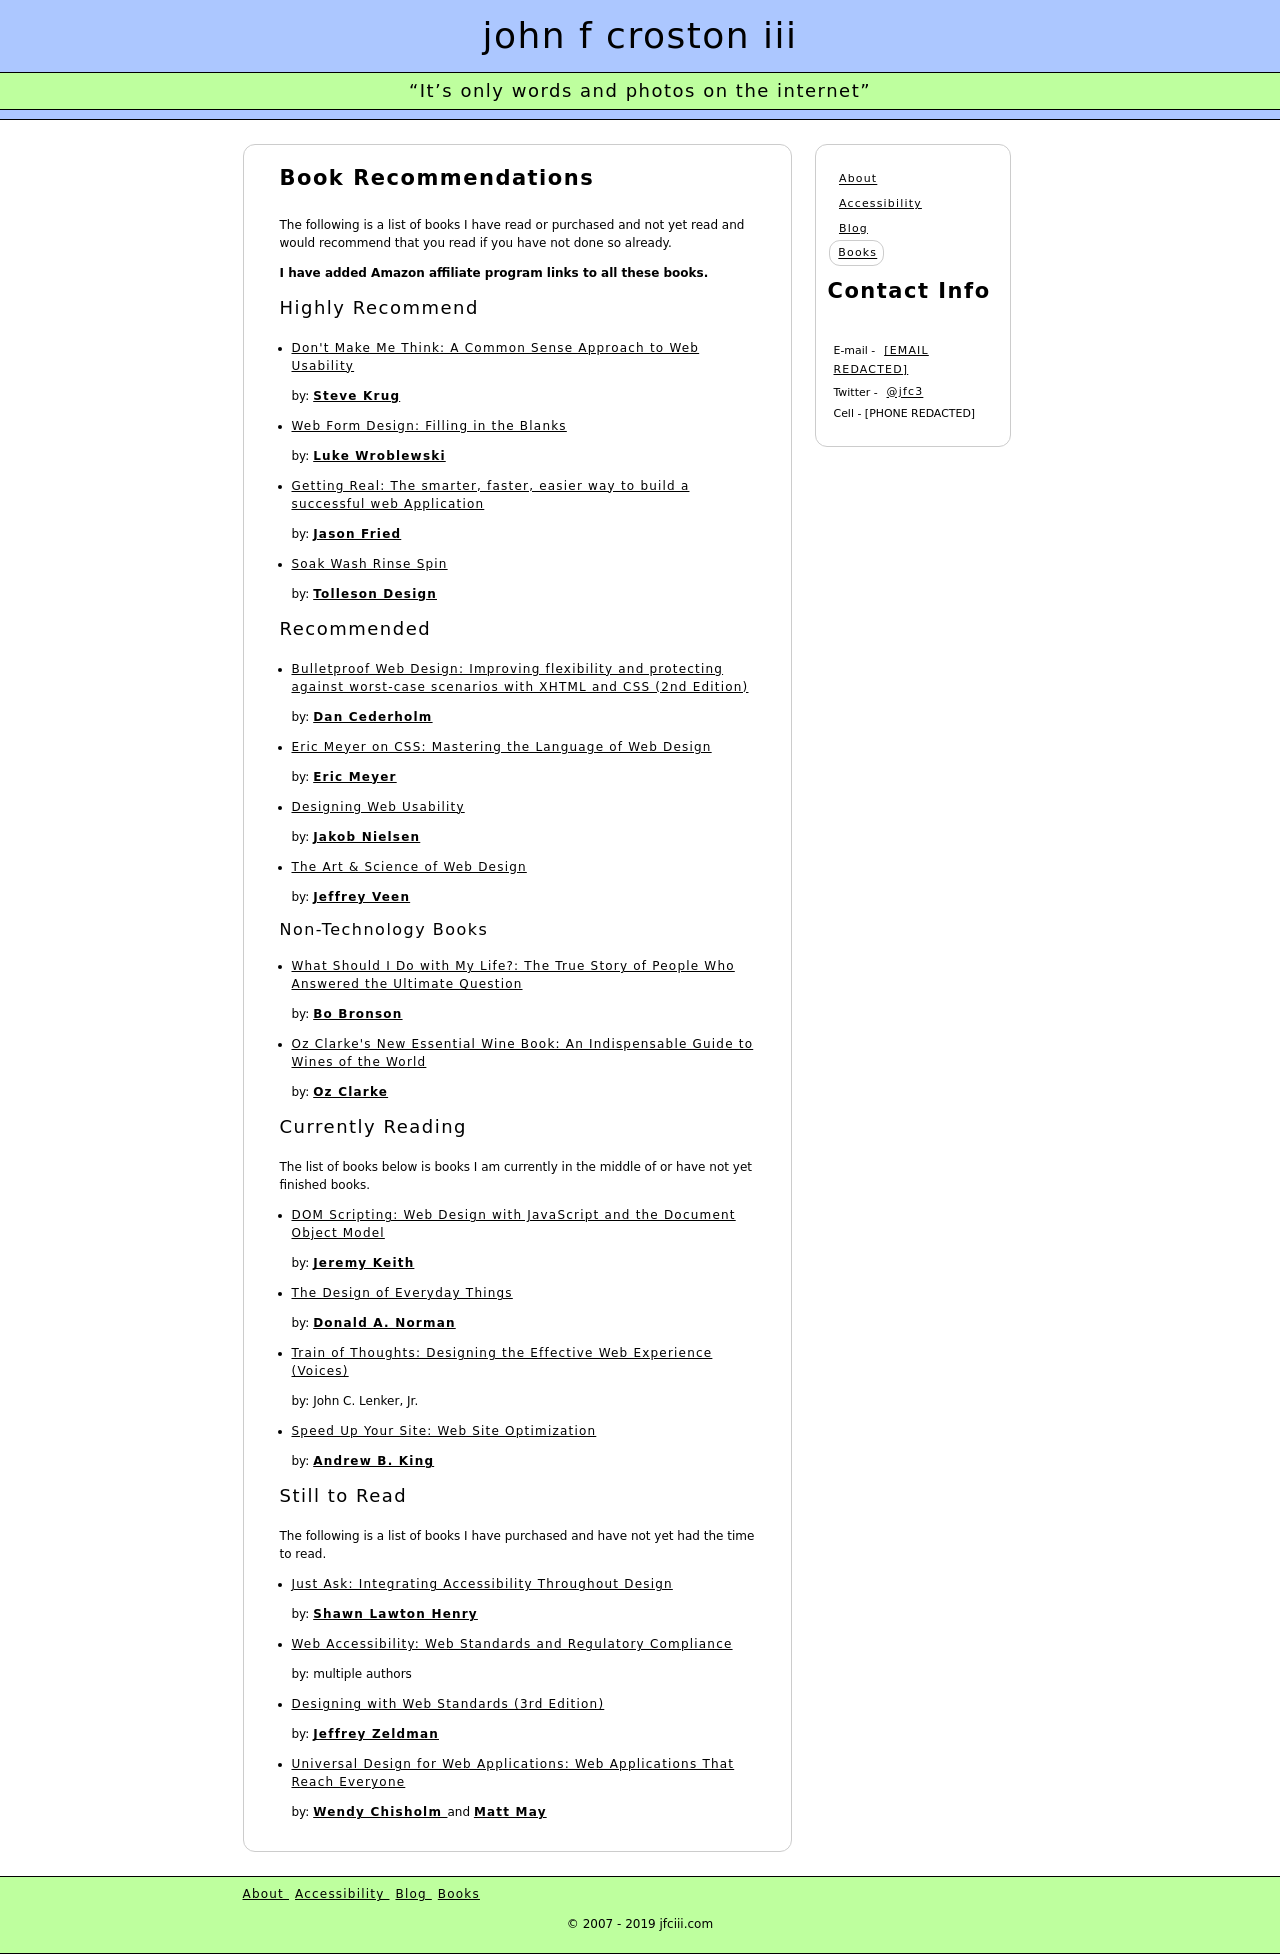Can you tell more about the book 'Don't Make Me Think' listed under Highly Recommend? 'Don't Make Me Think' by Steve Krug is a widely acclaimed book that discusses web usability. It's designed to be a practical guide to help web developers create intuitive and user-friendly websites. The book emphasizes the importance of clarity in web design and offers strategies for streamlined navigation and designing pages that are understandable at a glance. How might its principles apply to the design of the website shown? The principles from 'Don't Make Me Think' could be applied in this website by ensuring that the navigation is straightforward, as evidenced by clear category headings and a concise layout that guides the user's eye naturally. Links are designed to be self-explanatory and the text is made to be easily readable, both of which are key tenets of Krug's advice. 